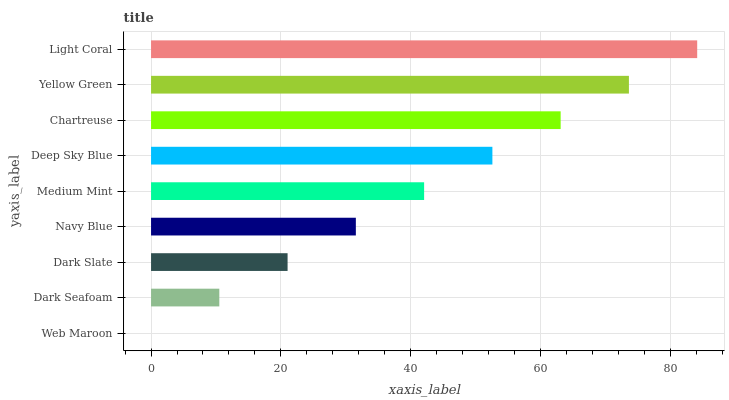Is Web Maroon the minimum?
Answer yes or no. Yes. Is Light Coral the maximum?
Answer yes or no. Yes. Is Dark Seafoam the minimum?
Answer yes or no. No. Is Dark Seafoam the maximum?
Answer yes or no. No. Is Dark Seafoam greater than Web Maroon?
Answer yes or no. Yes. Is Web Maroon less than Dark Seafoam?
Answer yes or no. Yes. Is Web Maroon greater than Dark Seafoam?
Answer yes or no. No. Is Dark Seafoam less than Web Maroon?
Answer yes or no. No. Is Medium Mint the high median?
Answer yes or no. Yes. Is Medium Mint the low median?
Answer yes or no. Yes. Is Dark Seafoam the high median?
Answer yes or no. No. Is Dark Seafoam the low median?
Answer yes or no. No. 